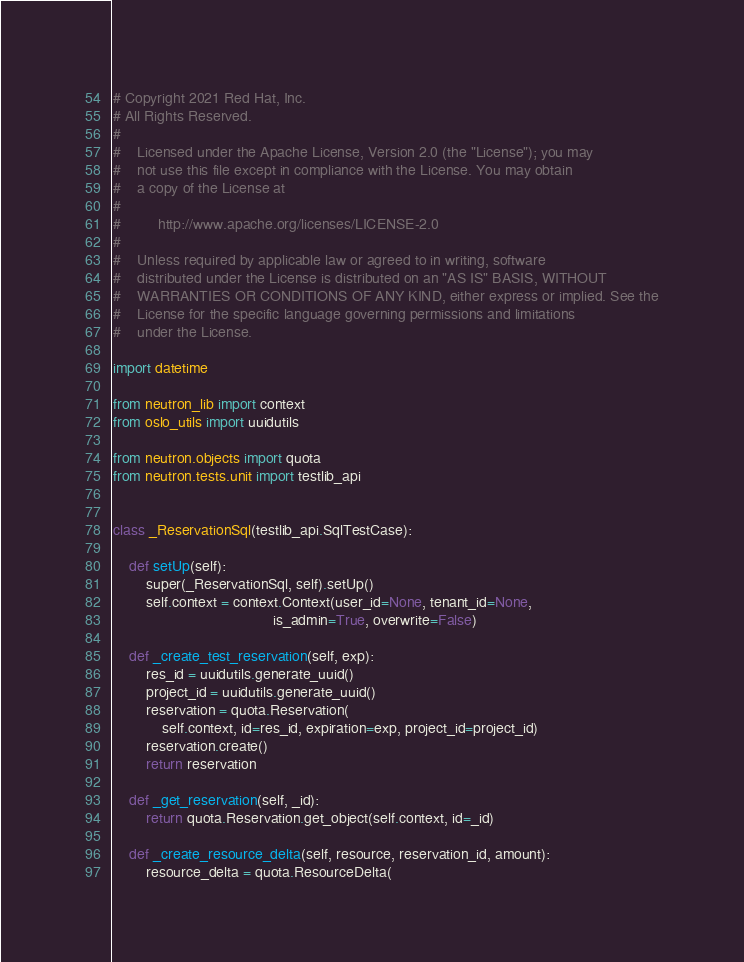<code> <loc_0><loc_0><loc_500><loc_500><_Python_># Copyright 2021 Red Hat, Inc.
# All Rights Reserved.
#
#    Licensed under the Apache License, Version 2.0 (the "License"); you may
#    not use this file except in compliance with the License. You may obtain
#    a copy of the License at
#
#         http://www.apache.org/licenses/LICENSE-2.0
#
#    Unless required by applicable law or agreed to in writing, software
#    distributed under the License is distributed on an "AS IS" BASIS, WITHOUT
#    WARRANTIES OR CONDITIONS OF ANY KIND, either express or implied. See the
#    License for the specific language governing permissions and limitations
#    under the License.

import datetime

from neutron_lib import context
from oslo_utils import uuidutils

from neutron.objects import quota
from neutron.tests.unit import testlib_api


class _ReservationSql(testlib_api.SqlTestCase):

    def setUp(self):
        super(_ReservationSql, self).setUp()
        self.context = context.Context(user_id=None, tenant_id=None,
                                       is_admin=True, overwrite=False)

    def _create_test_reservation(self, exp):
        res_id = uuidutils.generate_uuid()
        project_id = uuidutils.generate_uuid()
        reservation = quota.Reservation(
            self.context, id=res_id, expiration=exp, project_id=project_id)
        reservation.create()
        return reservation

    def _get_reservation(self, _id):
        return quota.Reservation.get_object(self.context, id=_id)

    def _create_resource_delta(self, resource, reservation_id, amount):
        resource_delta = quota.ResourceDelta(</code> 